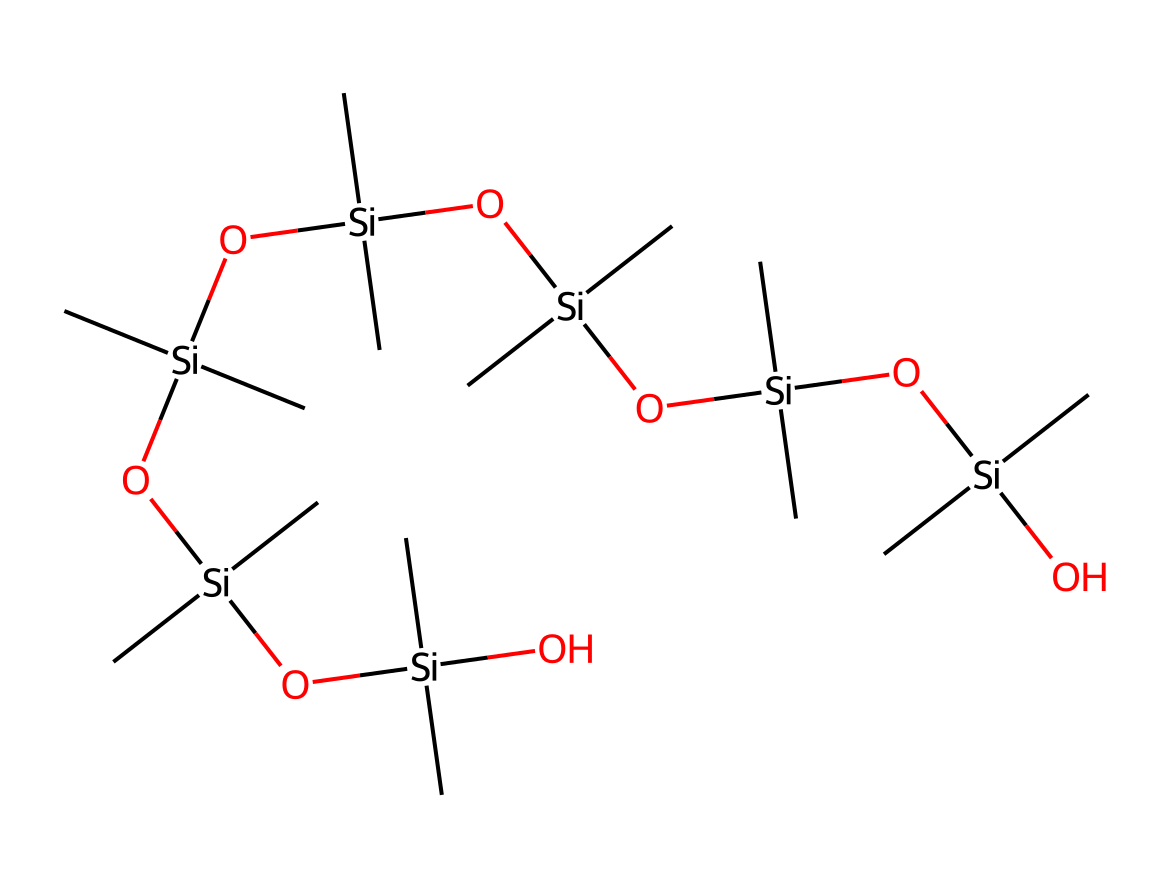What type of atom is the central component of this structure? The central atom in this structure is silicon, as evidenced by the presence of the Si notation throughout the SMILES representation.
Answer: silicon How many silicon atoms are present? Counting the instances of "Si" in the given SMILES indicates there are multiple silicon atoms; there are six Si atoms present in total.
Answer: six What is the main functional group present in this silicone polymer? The primary functional group is hydroxy (-OH), as indicated by the presence of "O" connected to "Si" in the structure.
Answer: hydroxy How many oxygen atoms are in the structure? By analyzing the SMILES representation, we can count the oxygen atoms linked to each silicon atom; there are five oxygen atoms overall in this molecule.
Answer: five What property does the presence of silicon impart to hair smoothing treatments? Silicon in hair smoothing treatments imparts properties like shine and smoothness due to its ability to form a protective coating on the hair.
Answer: shine What structural feature contributes to the versatility of silicon-based polymers? The repeating units of silicon and oxygen atoms form a flexible chain structure that enhances versatility in different types of formulations.
Answer: flexible chain 